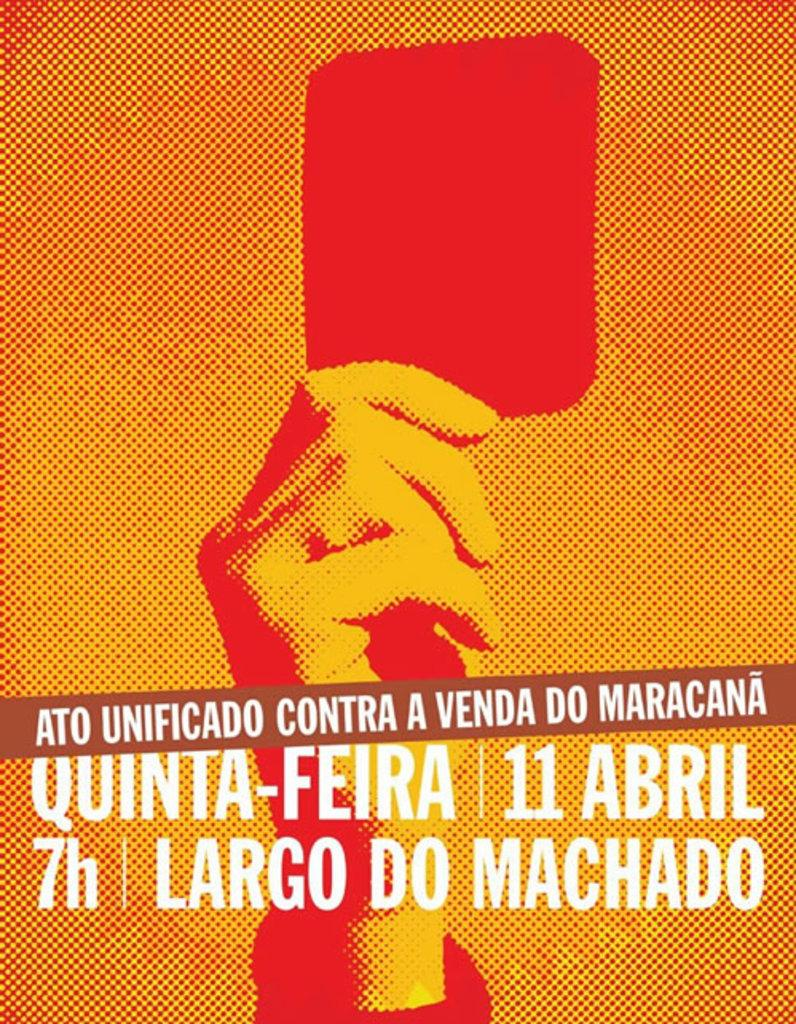What is the main subject of the image? The main subject of the image is the hand of a human being. What is the hand holding? The hand is holding a red color card. Is there any text present in the image? Yes, there is text written on the image. Can you see any flames in the image? No, there are no flames present in the image. What type of honey is being used in the image? There is no honey present in the image. 